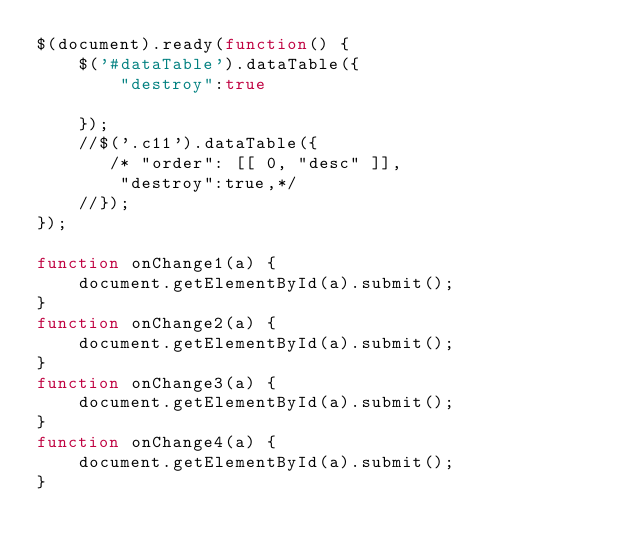Convert code to text. <code><loc_0><loc_0><loc_500><loc_500><_JavaScript_>$(document).ready(function() {
    $('#dataTable').dataTable({
        "destroy":true
        
    });
    //$('.c11').dataTable({        
       /* "order": [[ 0, "desc" ]],
        "destroy":true,*/
    //});
});

function onChange1(a) {
    document.getElementById(a).submit();
}
function onChange2(a) {
    document.getElementById(a).submit();
}
function onChange3(a) {
    document.getElementById(a).submit();
}
function onChange4(a) {
    document.getElementById(a).submit();
}

 


</code> 